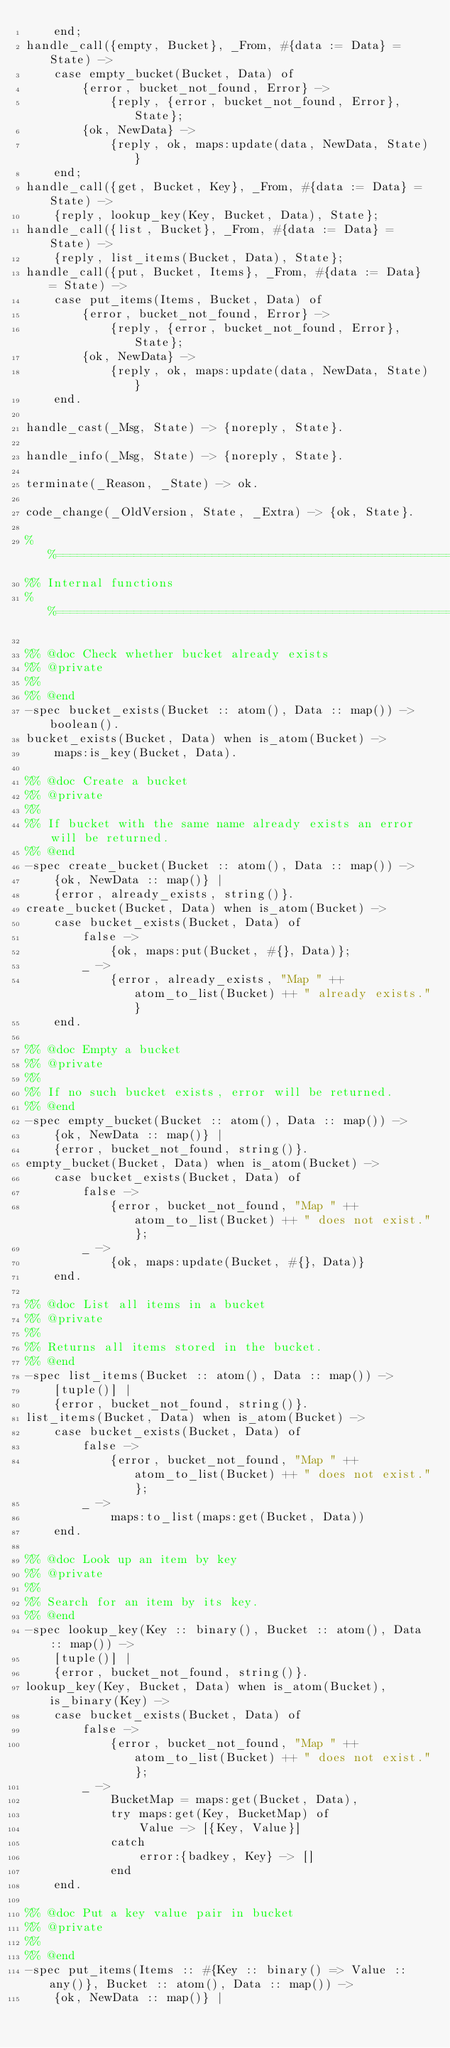Convert code to text. <code><loc_0><loc_0><loc_500><loc_500><_Erlang_>    end;
handle_call({empty, Bucket}, _From, #{data := Data} = State) ->
    case empty_bucket(Bucket, Data) of
        {error, bucket_not_found, Error} ->
            {reply, {error, bucket_not_found, Error}, State};
        {ok, NewData} ->
            {reply, ok, maps:update(data, NewData, State)}
    end;
handle_call({get, Bucket, Key}, _From, #{data := Data} = State) ->
    {reply, lookup_key(Key, Bucket, Data), State};
handle_call({list, Bucket}, _From, #{data := Data} = State) ->
    {reply, list_items(Bucket, Data), State};
handle_call({put, Bucket, Items}, _From, #{data := Data} = State) ->
    case put_items(Items, Bucket, Data) of
        {error, bucket_not_found, Error} ->
            {reply, {error, bucket_not_found, Error}, State};
        {ok, NewData} ->
            {reply, ok, maps:update(data, NewData, State)}
    end.

handle_cast(_Msg, State) -> {noreply, State}.

handle_info(_Msg, State) -> {noreply, State}.

terminate(_Reason, _State) -> ok.

code_change(_OldVersion, State, _Extra) -> {ok, State}.

%%===================================================================
%% Internal functions
%%===================================================================

%% @doc Check whether bucket already exists
%% @private
%%
%% @end
-spec bucket_exists(Bucket :: atom(), Data :: map()) -> boolean().
bucket_exists(Bucket, Data) when is_atom(Bucket) ->
    maps:is_key(Bucket, Data).

%% @doc Create a bucket
%% @private
%%
%% If bucket with the same name already exists an error will be returned.
%% @end
-spec create_bucket(Bucket :: atom(), Data :: map()) ->
    {ok, NewData :: map()} |
    {error, already_exists, string()}.
create_bucket(Bucket, Data) when is_atom(Bucket) ->
    case bucket_exists(Bucket, Data) of
        false ->
            {ok, maps:put(Bucket, #{}, Data)};
        _ ->
            {error, already_exists, "Map " ++ atom_to_list(Bucket) ++ " already exists."}
    end.

%% @doc Empty a bucket
%% @private
%%
%% If no such bucket exists, error will be returned.
%% @end
-spec empty_bucket(Bucket :: atom(), Data :: map()) ->
    {ok, NewData :: map()} |
    {error, bucket_not_found, string()}.
empty_bucket(Bucket, Data) when is_atom(Bucket) ->
    case bucket_exists(Bucket, Data) of
        false ->
            {error, bucket_not_found, "Map " ++ atom_to_list(Bucket) ++ " does not exist."};
        _ ->
            {ok, maps:update(Bucket, #{}, Data)}
    end.

%% @doc List all items in a bucket
%% @private
%%
%% Returns all items stored in the bucket.
%% @end
-spec list_items(Bucket :: atom(), Data :: map()) ->
    [tuple()] |
    {error, bucket_not_found, string()}.
list_items(Bucket, Data) when is_atom(Bucket) ->
    case bucket_exists(Bucket, Data) of
        false ->
            {error, bucket_not_found, "Map " ++ atom_to_list(Bucket) ++ " does not exist."};
        _ ->
            maps:to_list(maps:get(Bucket, Data))
    end.

%% @doc Look up an item by key
%% @private
%%
%% Search for an item by its key.
%% @end
-spec lookup_key(Key :: binary(), Bucket :: atom(), Data :: map()) ->
    [tuple()] |
    {error, bucket_not_found, string()}.
lookup_key(Key, Bucket, Data) when is_atom(Bucket), is_binary(Key) ->
    case bucket_exists(Bucket, Data) of
        false ->
            {error, bucket_not_found, "Map " ++ atom_to_list(Bucket) ++ " does not exist."};
        _ ->
            BucketMap = maps:get(Bucket, Data),
            try maps:get(Key, BucketMap) of
                Value -> [{Key, Value}]
            catch
                error:{badkey, Key} -> []
            end
    end.

%% @doc Put a key value pair in bucket
%% @private
%%
%% @end
-spec put_items(Items :: #{Key :: binary() => Value :: any()}, Bucket :: atom(), Data :: map()) ->
    {ok, NewData :: map()} |</code> 